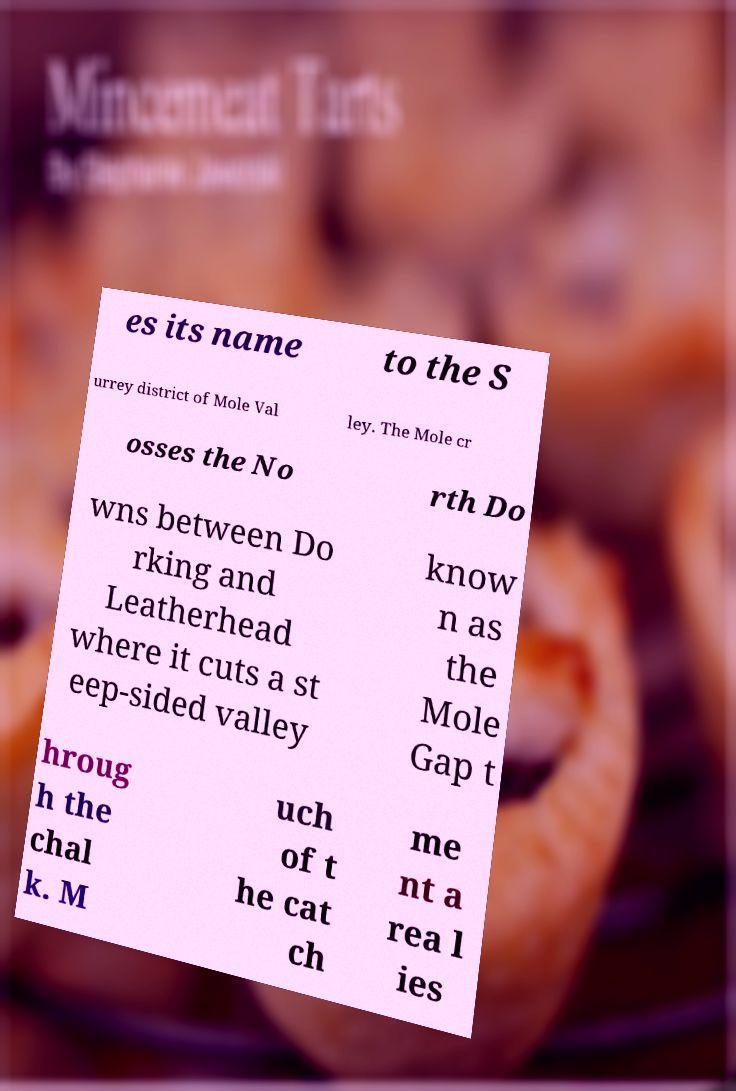Could you assist in decoding the text presented in this image and type it out clearly? es its name to the S urrey district of Mole Val ley. The Mole cr osses the No rth Do wns between Do rking and Leatherhead where it cuts a st eep-sided valley know n as the Mole Gap t hroug h the chal k. M uch of t he cat ch me nt a rea l ies 